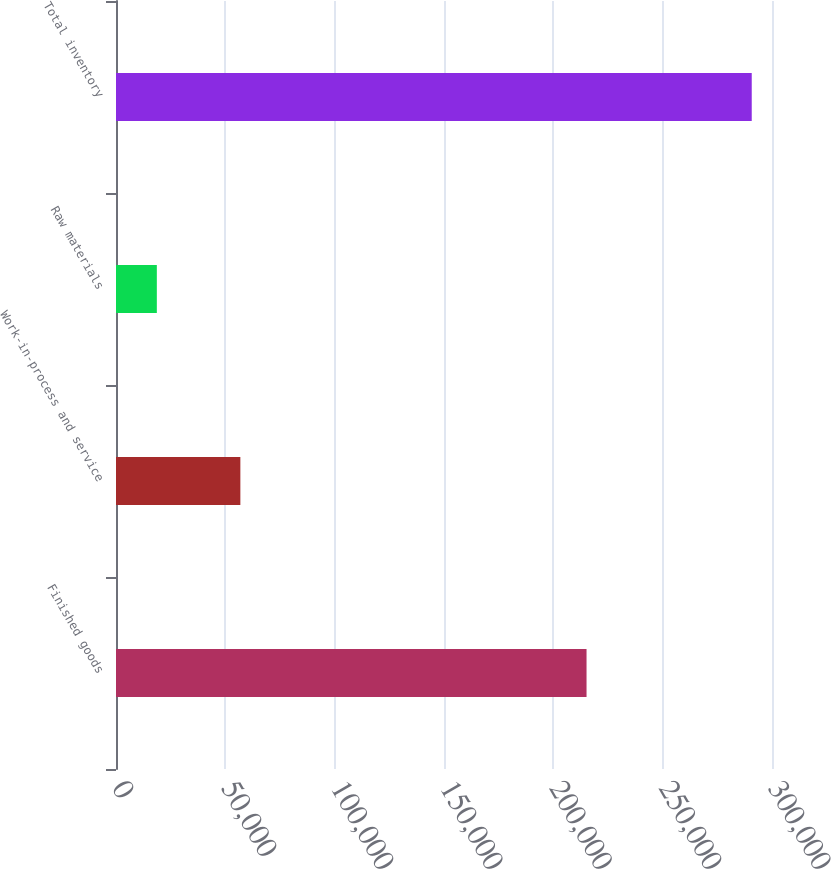Convert chart. <chart><loc_0><loc_0><loc_500><loc_500><bar_chart><fcel>Finished goods<fcel>Work-in-process and service<fcel>Raw materials<fcel>Total inventory<nl><fcel>215186<fcel>56871<fcel>18676<fcel>290733<nl></chart> 